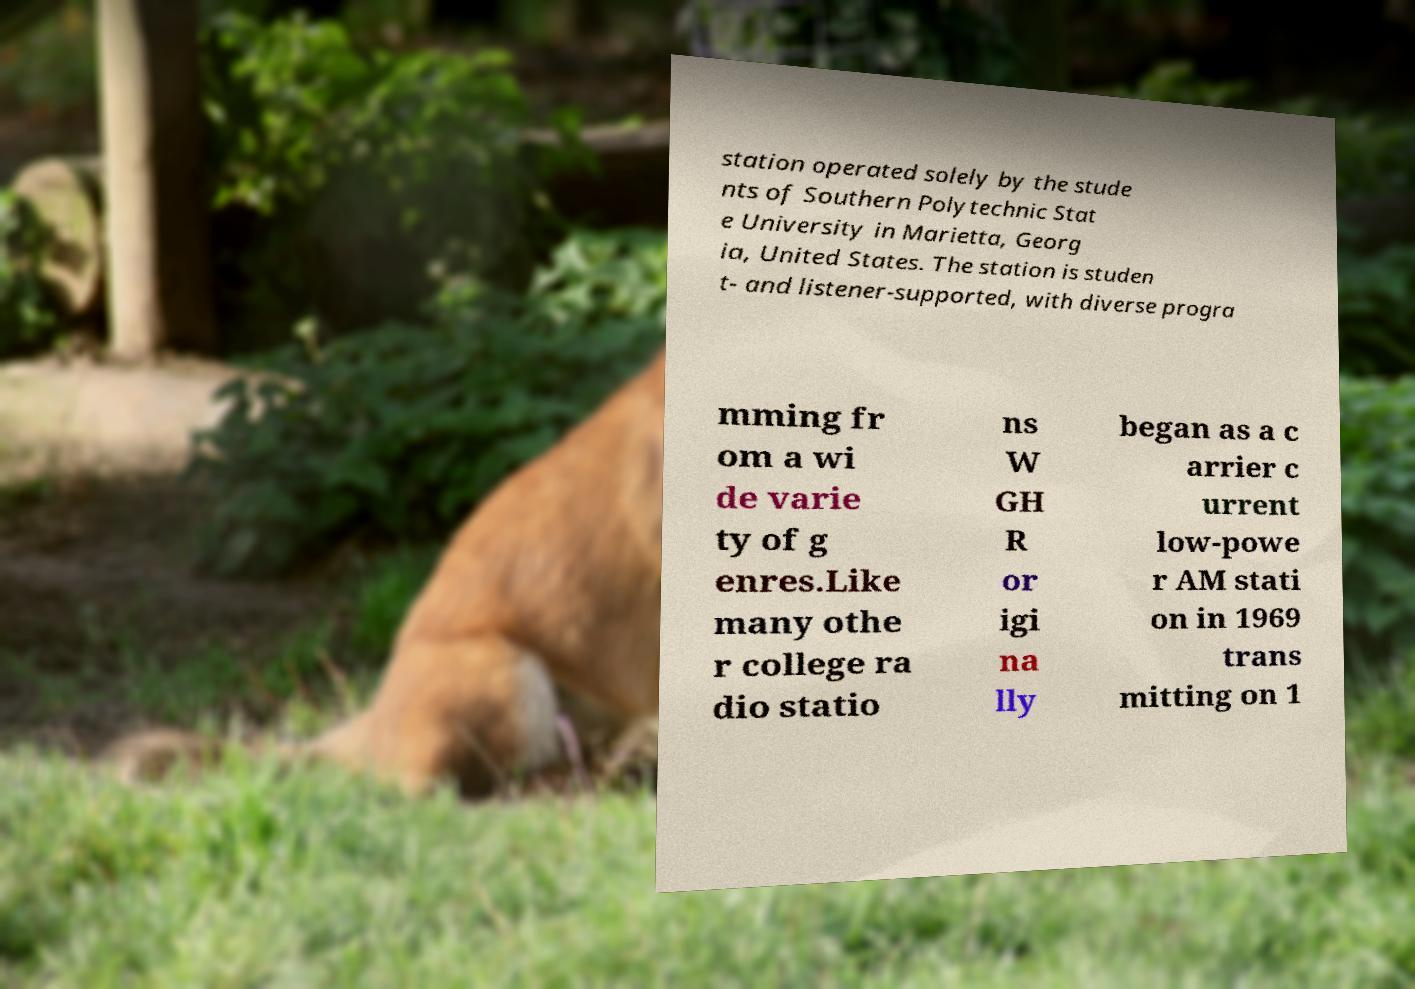Please identify and transcribe the text found in this image. station operated solely by the stude nts of Southern Polytechnic Stat e University in Marietta, Georg ia, United States. The station is studen t- and listener-supported, with diverse progra mming fr om a wi de varie ty of g enres.Like many othe r college ra dio statio ns W GH R or igi na lly began as a c arrier c urrent low-powe r AM stati on in 1969 trans mitting on 1 